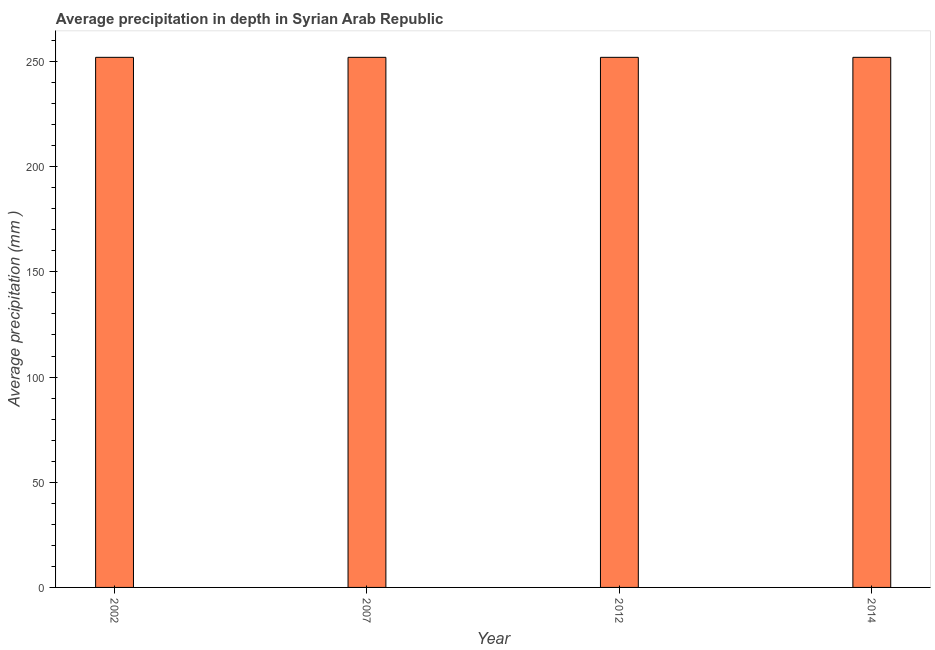Does the graph contain grids?
Your response must be concise. No. What is the title of the graph?
Your answer should be compact. Average precipitation in depth in Syrian Arab Republic. What is the label or title of the Y-axis?
Provide a succinct answer. Average precipitation (mm ). What is the average precipitation in depth in 2012?
Provide a short and direct response. 252. Across all years, what is the maximum average precipitation in depth?
Provide a succinct answer. 252. Across all years, what is the minimum average precipitation in depth?
Ensure brevity in your answer.  252. In which year was the average precipitation in depth maximum?
Offer a very short reply. 2002. In which year was the average precipitation in depth minimum?
Your response must be concise. 2002. What is the sum of the average precipitation in depth?
Your answer should be compact. 1008. What is the difference between the average precipitation in depth in 2012 and 2014?
Make the answer very short. 0. What is the average average precipitation in depth per year?
Provide a short and direct response. 252. What is the median average precipitation in depth?
Offer a terse response. 252. In how many years, is the average precipitation in depth greater than 210 mm?
Keep it short and to the point. 4. Is the average precipitation in depth in 2007 less than that in 2012?
Make the answer very short. No. What is the difference between the highest and the lowest average precipitation in depth?
Offer a very short reply. 0. How many bars are there?
Ensure brevity in your answer.  4. Are all the bars in the graph horizontal?
Provide a succinct answer. No. What is the Average precipitation (mm ) of 2002?
Your response must be concise. 252. What is the Average precipitation (mm ) of 2007?
Provide a succinct answer. 252. What is the Average precipitation (mm ) in 2012?
Your answer should be compact. 252. What is the Average precipitation (mm ) of 2014?
Give a very brief answer. 252. What is the difference between the Average precipitation (mm ) in 2002 and 2007?
Your answer should be compact. 0. What is the difference between the Average precipitation (mm ) in 2002 and 2012?
Make the answer very short. 0. What is the difference between the Average precipitation (mm ) in 2002 and 2014?
Provide a succinct answer. 0. What is the difference between the Average precipitation (mm ) in 2007 and 2014?
Offer a terse response. 0. What is the difference between the Average precipitation (mm ) in 2012 and 2014?
Your answer should be very brief. 0. What is the ratio of the Average precipitation (mm ) in 2002 to that in 2007?
Ensure brevity in your answer.  1. What is the ratio of the Average precipitation (mm ) in 2002 to that in 2012?
Offer a terse response. 1. What is the ratio of the Average precipitation (mm ) in 2007 to that in 2014?
Keep it short and to the point. 1. What is the ratio of the Average precipitation (mm ) in 2012 to that in 2014?
Provide a short and direct response. 1. 